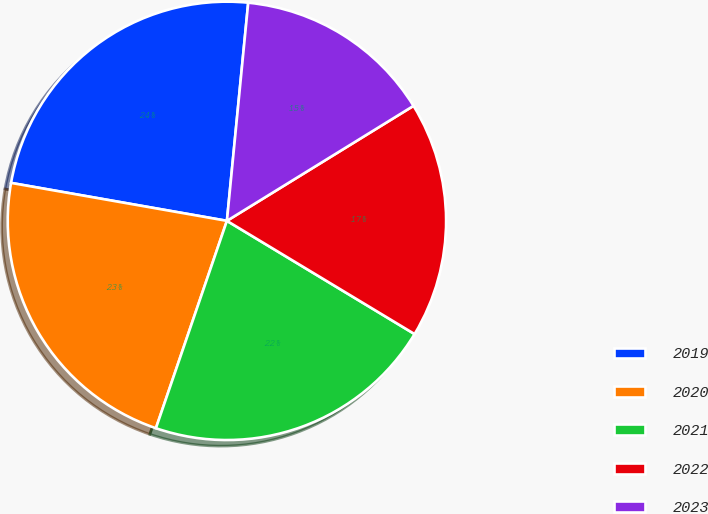Convert chart to OTSL. <chart><loc_0><loc_0><loc_500><loc_500><pie_chart><fcel>2019<fcel>2020<fcel>2021<fcel>2022<fcel>2023<nl><fcel>23.78%<fcel>22.52%<fcel>21.61%<fcel>17.43%<fcel>14.66%<nl></chart> 